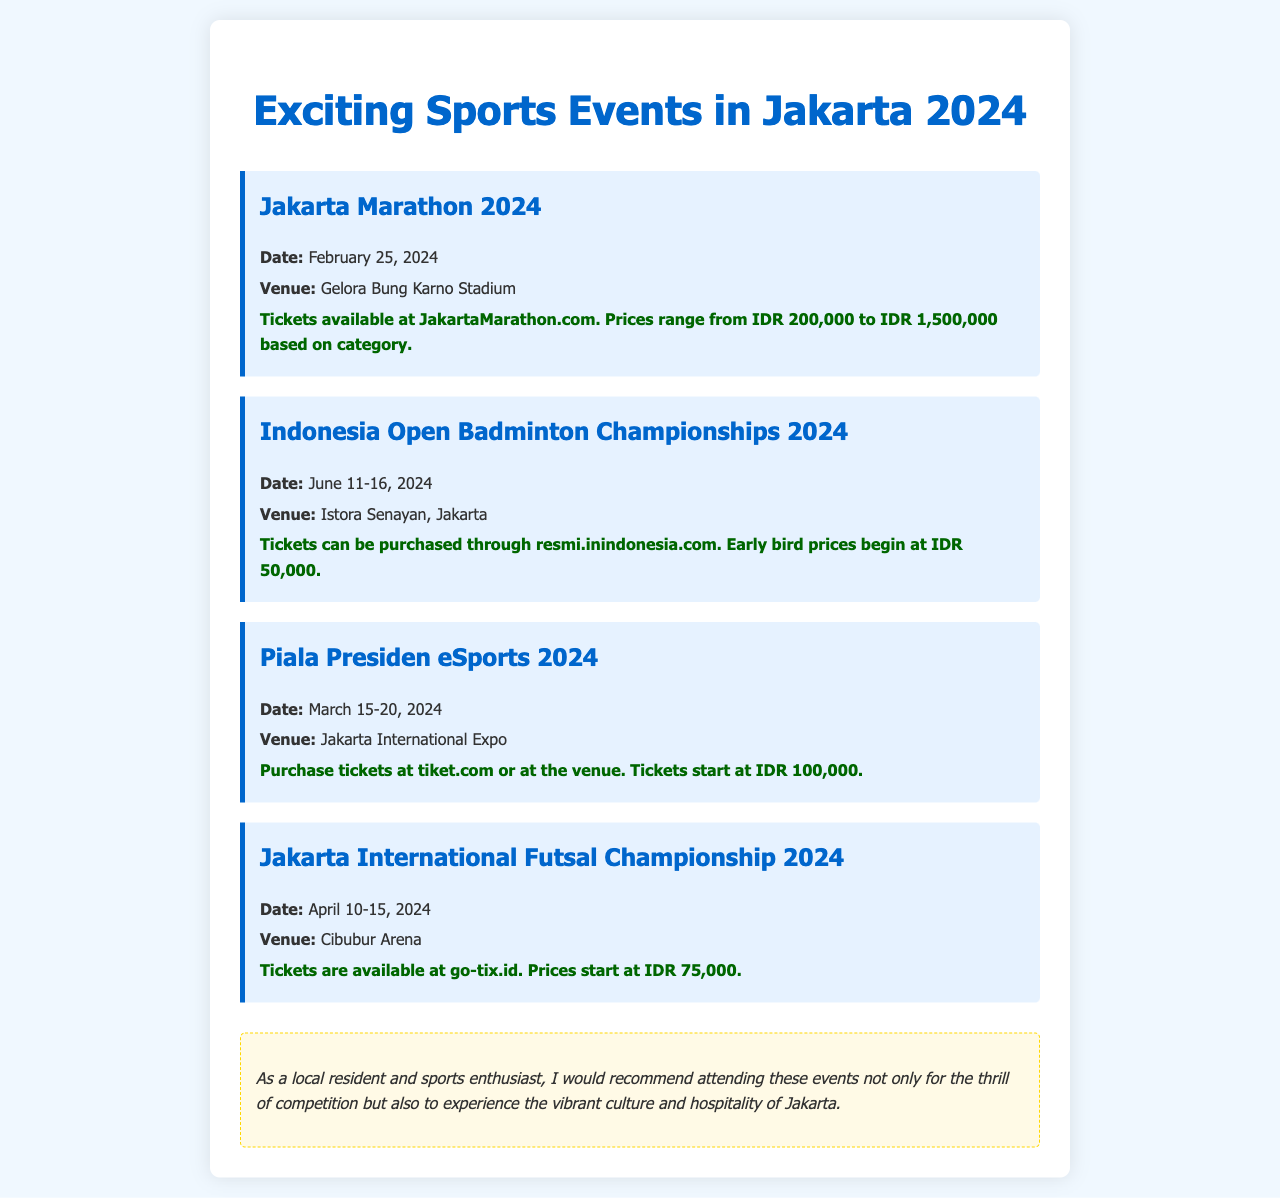What is the date of the Jakarta Marathon 2024? The date for the Jakarta Marathon 2024 is specifically mentioned in the document.
Answer: February 25, 2024 Where will the Indonesia Open Badminton Championships take place? The venue for this event is clearly stated in the document.
Answer: Istora Senayan, Jakarta How much do tickets for the Piala Presiden eSports start at? The document provides specific ticket prices for this event.
Answer: IDR 100,000 When is the Jakarta International Futsal Championship scheduled? The schedule for the event is indicated in the document.
Answer: April 10-15, 2024 Which event occurs first in the 2024 schedule? This requires comparing the dates of each event laid out in the document.
Answer: Jakarta Marathon 2024 What is the maximum ticket price for the Jakarta Marathon? The document specifies the price range for tickets, indicating the maximum price.
Answer: IDR 1,500,000 How can tickets for the Jakarta International Futsal Championship be purchased? The document details the method of ticket purchase for this event.
Answer: go-tix.id What type of event is scheduled for March 15-20, 2024? This requires recalling the specific event mentioned during that date range.
Answer: Piala Presiden eSports 2024 What recommendation is provided for attending the events? The document includes an insight that highlights a reason for attending the events.
Answer: experience the vibrant culture and hospitality of Jakarta 